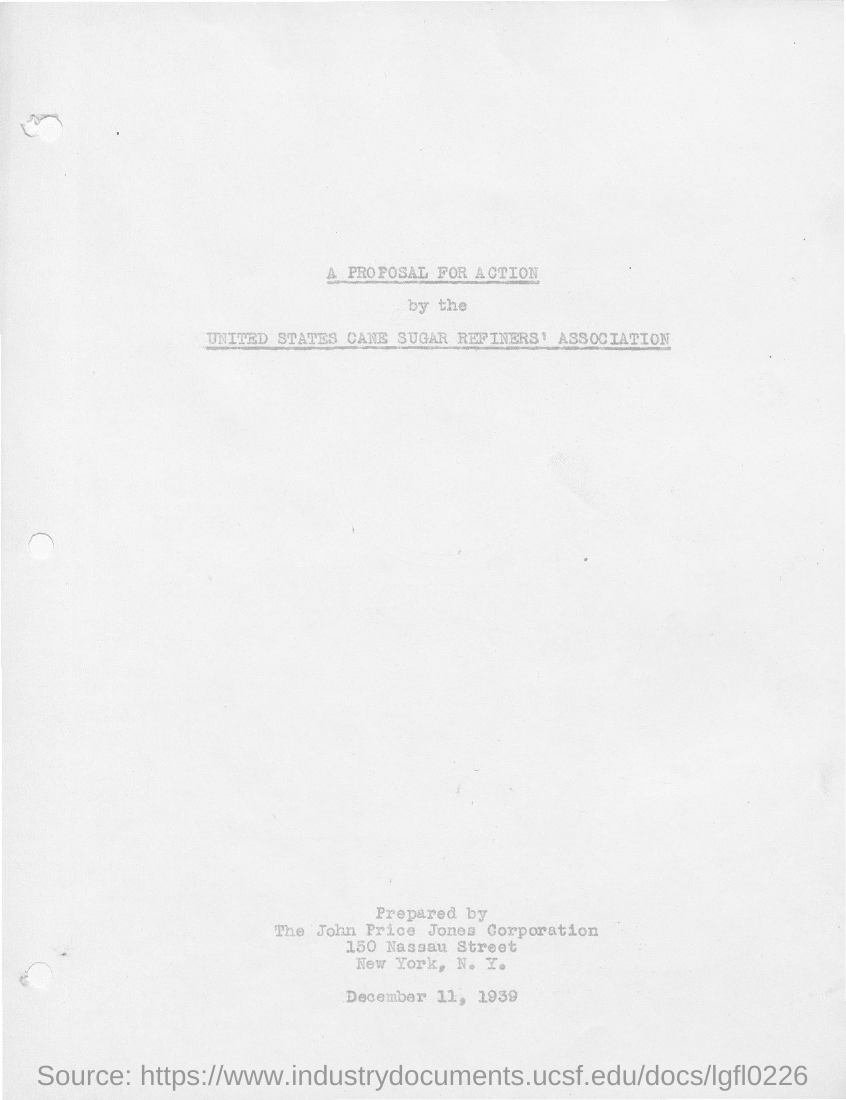Who prepared the proposal for action by the United States Cane Sugar Refiners' Association?
Keep it short and to the point. The John Price Jones Corporation. 